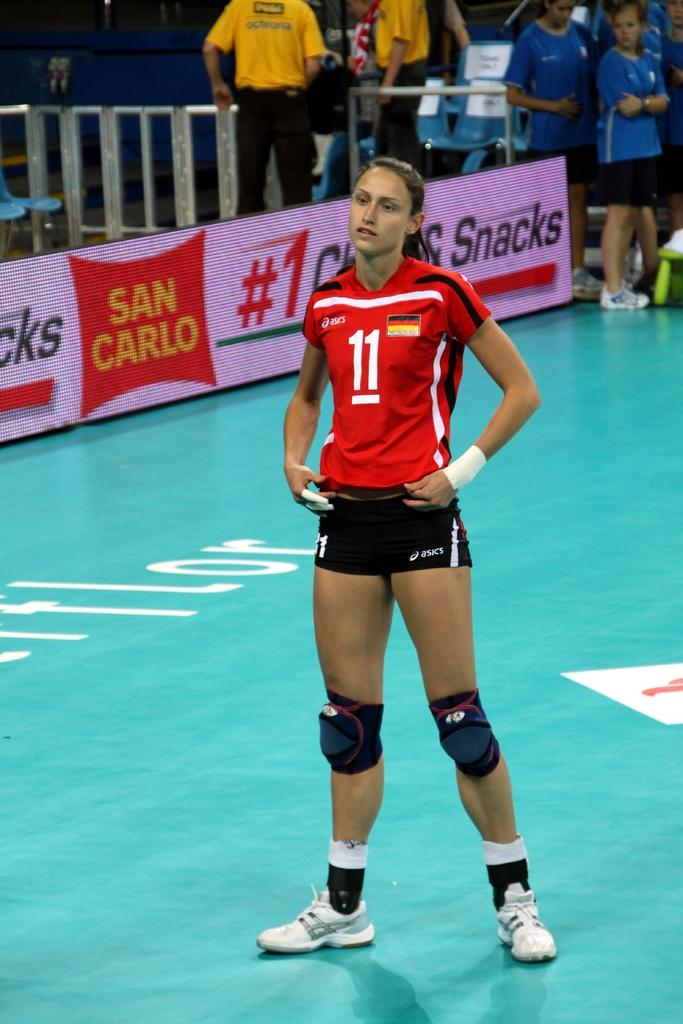<image>
Summarize the visual content of the image. A girl stands on a court in asics branded clothes. 